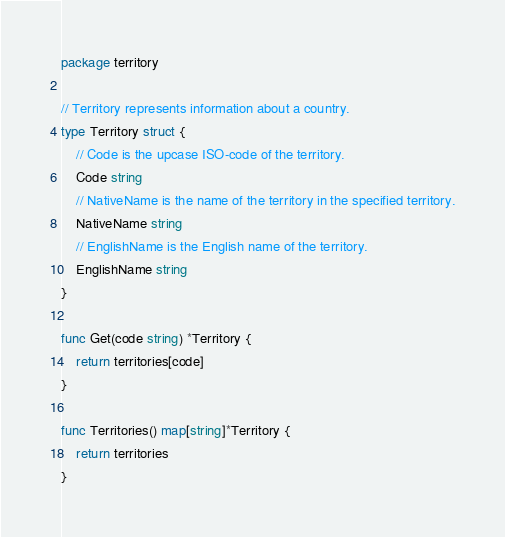Convert code to text. <code><loc_0><loc_0><loc_500><loc_500><_Go_>package territory

// Territory represents information about a country.
type Territory struct {
	// Code is the upcase ISO-code of the territory.
	Code string
	// NativeName is the name of the territory in the specified territory.
	NativeName string
	// EnglishName is the English name of the territory.
	EnglishName string
}

func Get(code string) *Territory {
	return territories[code]
}

func Territories() map[string]*Territory {
	return territories
}
</code> 